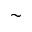Convert formula to latex. <formula><loc_0><loc_0><loc_500><loc_500>\sim</formula> 